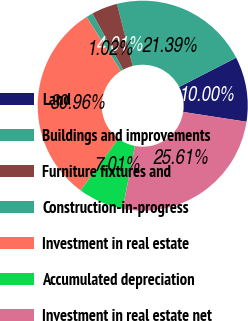<chart> <loc_0><loc_0><loc_500><loc_500><pie_chart><fcel>Land<fcel>Buildings and improvements<fcel>Furniture fixtures and<fcel>Construction-in-progress<fcel>Investment in real estate<fcel>Accumulated depreciation<fcel>Investment in real estate net<nl><fcel>10.0%<fcel>21.39%<fcel>4.01%<fcel>1.02%<fcel>30.96%<fcel>7.01%<fcel>25.61%<nl></chart> 